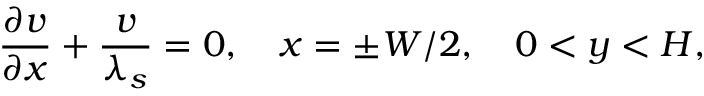<formula> <loc_0><loc_0><loc_500><loc_500>\frac { \partial v } { \partial x } + \frac { v } { \lambda _ { s } } = 0 , x = \pm W / 2 , 0 < y < H ,</formula> 